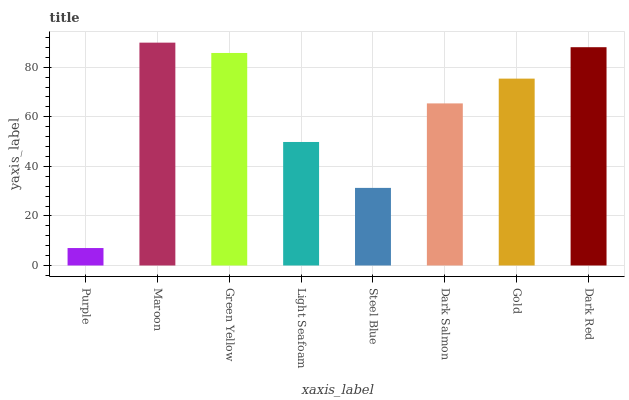Is Purple the minimum?
Answer yes or no. Yes. Is Maroon the maximum?
Answer yes or no. Yes. Is Green Yellow the minimum?
Answer yes or no. No. Is Green Yellow the maximum?
Answer yes or no. No. Is Maroon greater than Green Yellow?
Answer yes or no. Yes. Is Green Yellow less than Maroon?
Answer yes or no. Yes. Is Green Yellow greater than Maroon?
Answer yes or no. No. Is Maroon less than Green Yellow?
Answer yes or no. No. Is Gold the high median?
Answer yes or no. Yes. Is Dark Salmon the low median?
Answer yes or no. Yes. Is Steel Blue the high median?
Answer yes or no. No. Is Steel Blue the low median?
Answer yes or no. No. 